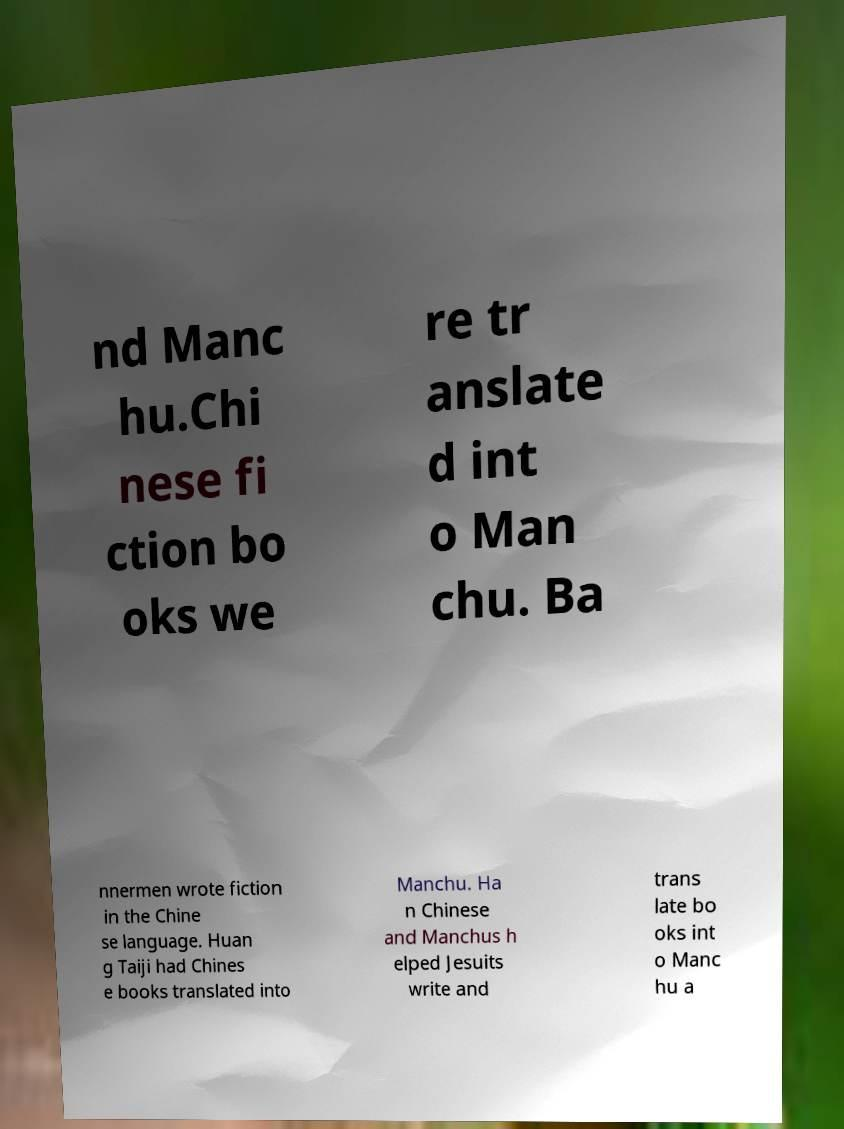Could you extract and type out the text from this image? nd Manc hu.Chi nese fi ction bo oks we re tr anslate d int o Man chu. Ba nnermen wrote fiction in the Chine se language. Huan g Taiji had Chines e books translated into Manchu. Ha n Chinese and Manchus h elped Jesuits write and trans late bo oks int o Manc hu a 